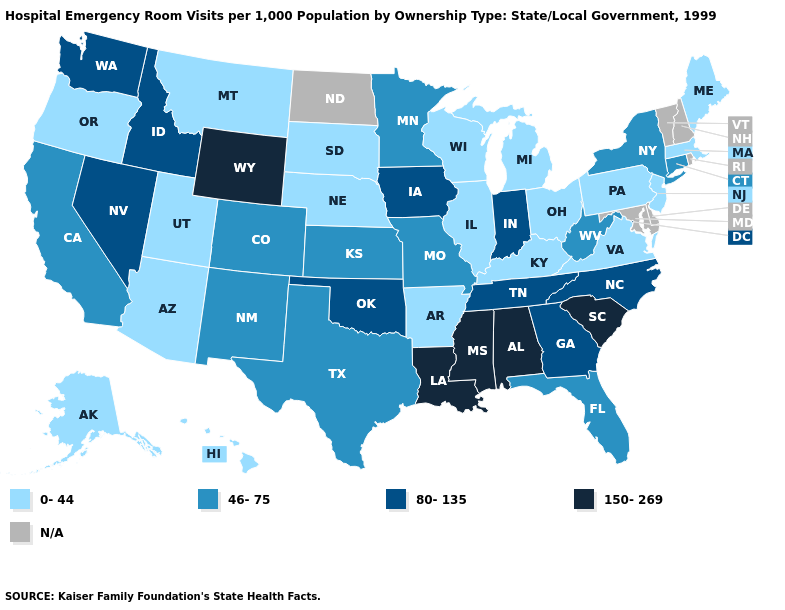What is the highest value in the MidWest ?
Give a very brief answer. 80-135. What is the value of Louisiana?
Keep it brief. 150-269. What is the value of Kansas?
Short answer required. 46-75. Name the states that have a value in the range N/A?
Quick response, please. Delaware, Maryland, New Hampshire, North Dakota, Rhode Island, Vermont. Among the states that border Maryland , does West Virginia have the lowest value?
Give a very brief answer. No. Among the states that border Mississippi , does Louisiana have the highest value?
Give a very brief answer. Yes. Name the states that have a value in the range 150-269?
Short answer required. Alabama, Louisiana, Mississippi, South Carolina, Wyoming. Among the states that border Alabama , which have the lowest value?
Be succinct. Florida. Does New Jersey have the highest value in the Northeast?
Keep it brief. No. Name the states that have a value in the range N/A?
Give a very brief answer. Delaware, Maryland, New Hampshire, North Dakota, Rhode Island, Vermont. Among the states that border Ohio , does Indiana have the highest value?
Answer briefly. Yes. What is the value of Montana?
Short answer required. 0-44. Does Wyoming have the highest value in the West?
Short answer required. Yes. What is the value of Colorado?
Short answer required. 46-75. What is the highest value in states that border New York?
Concise answer only. 46-75. 